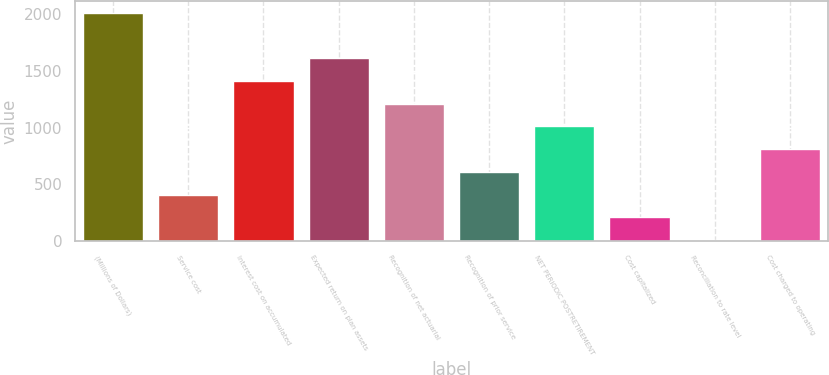Convert chart. <chart><loc_0><loc_0><loc_500><loc_500><bar_chart><fcel>(Millions of Dollars)<fcel>Service cost<fcel>Interest cost on accumulated<fcel>Expected return on plan assets<fcel>Recognition of net actuarial<fcel>Recognition of prior service<fcel>NET PERIODIC POSTRETIREMENT<fcel>Cost capitalized<fcel>Reconciliation to rate level<fcel>Cost charged to operating<nl><fcel>2014<fcel>410.8<fcel>1412.8<fcel>1613.2<fcel>1212.4<fcel>611.2<fcel>1012<fcel>210.4<fcel>10<fcel>811.6<nl></chart> 